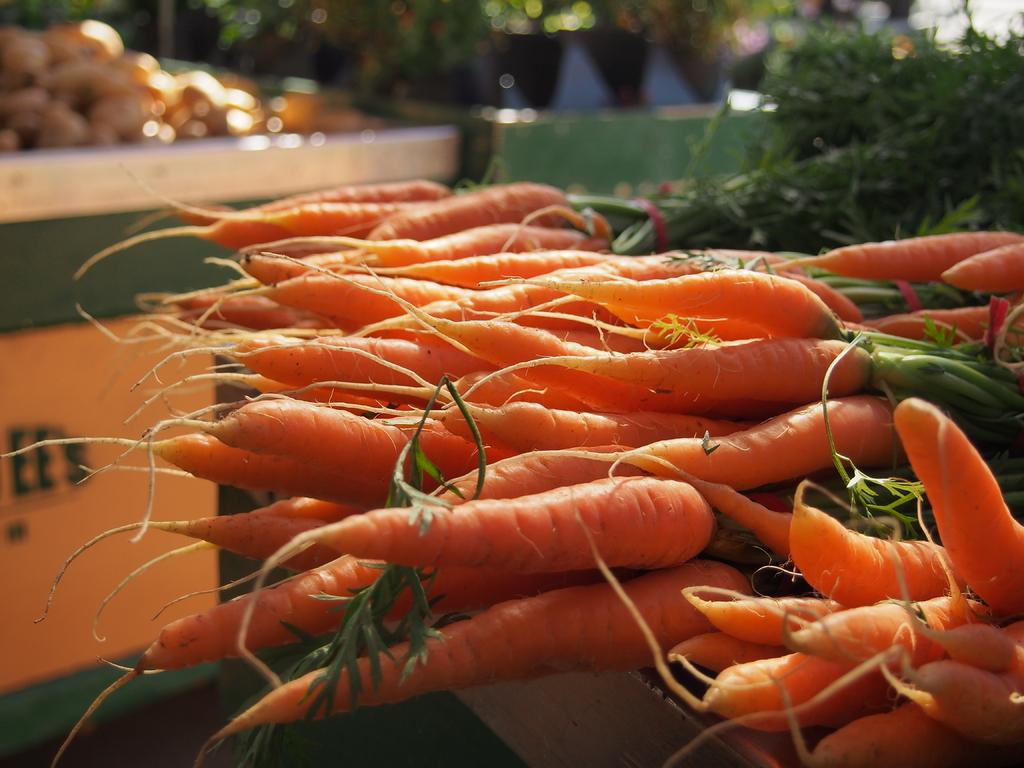What type of vegetables are in the image? There are orange-colored carrots in the image. What else is present in the image besides the carrots? There are plants in the image. How are the carrots and plants arranged in the image? The carrots and plants are arranged on a surface. Where is the surface located in the image? The surface is on the right side of the image. What can be observed about the background of the image? The background of the image is blurred. What type of mask is being worn by the carrot in the image? There are no masks or people present in the image; it features carrots and plants arranged on a surface. Can you read the letter that is being held by the plant in the image? There are no letters or people holding letters in the image; it features carrots and plants arranged on a surface. 